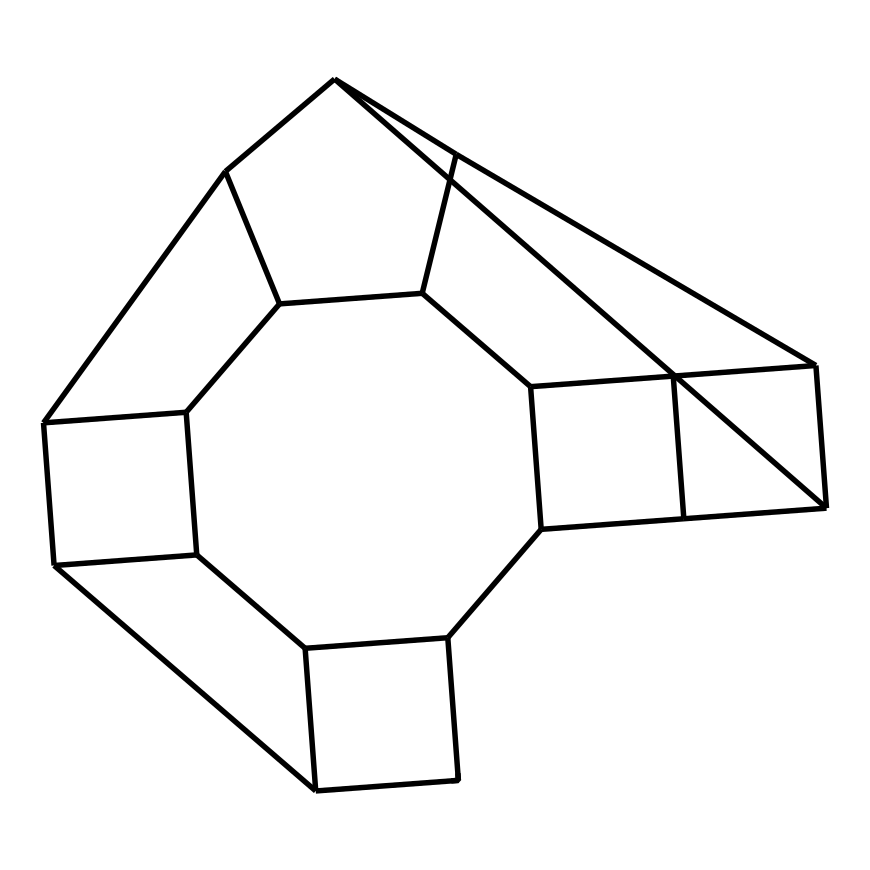What is the molecular formula of dodecahedrane? Dodecahedrane, a cage compound, consists of 12 carbon atoms and 24 hydrogen atoms based on the chemical structure. Reading from the SMILES notation, we can determine the number of carbon and hydrogen atoms present.
Answer: C12H24 How many faces does dodecahedrane have? The structure of dodecahedrane resembles a dodecahedron, which is a polyhedron with 12 faces. Observing the geometry of the compound aligns with the properties of its name and molecular structure.
Answer: 12 What type of hybridization is present in dodecahedrane's carbon atoms? The carbon atoms in dodecahedrane are involved in sp3 hybridization, which is characteristic of saturated carbons forming single bonds. Investigating the bond angles and connections in the structure confirms the sp3 hybridization.
Answer: sp3 What is the symmetry class of dodecahedrane? Dodecahedrane exhibits icosahedral symmetry, which is a high degree of symmetry pertinent to its cage-like structure. Recognizing the symmetrical arrangement of the atoms provides insights into its classification.
Answer: icosahedral What unique property of dodecahedrane could be advantageous for quantum computing? Dodecahedrane has potential for quantum coherence and manipulation due to its symmetrical and confined structure, which allows for stable qubit configurations. Analyzing the arrangement emphasizes its capabilities in such advanced applications.
Answer: stability 